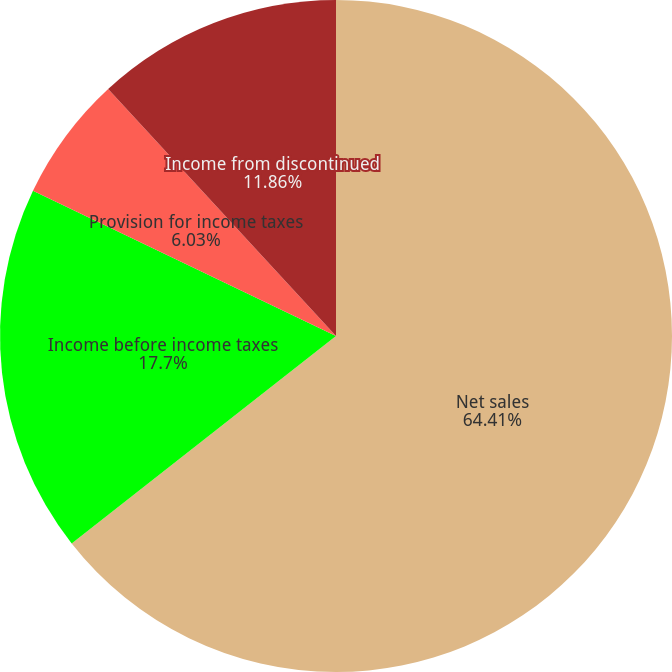Convert chart to OTSL. <chart><loc_0><loc_0><loc_500><loc_500><pie_chart><fcel>Net sales<fcel>Income before income taxes<fcel>Provision for income taxes<fcel>Income from discontinued<nl><fcel>64.41%<fcel>17.7%<fcel>6.03%<fcel>11.86%<nl></chart> 